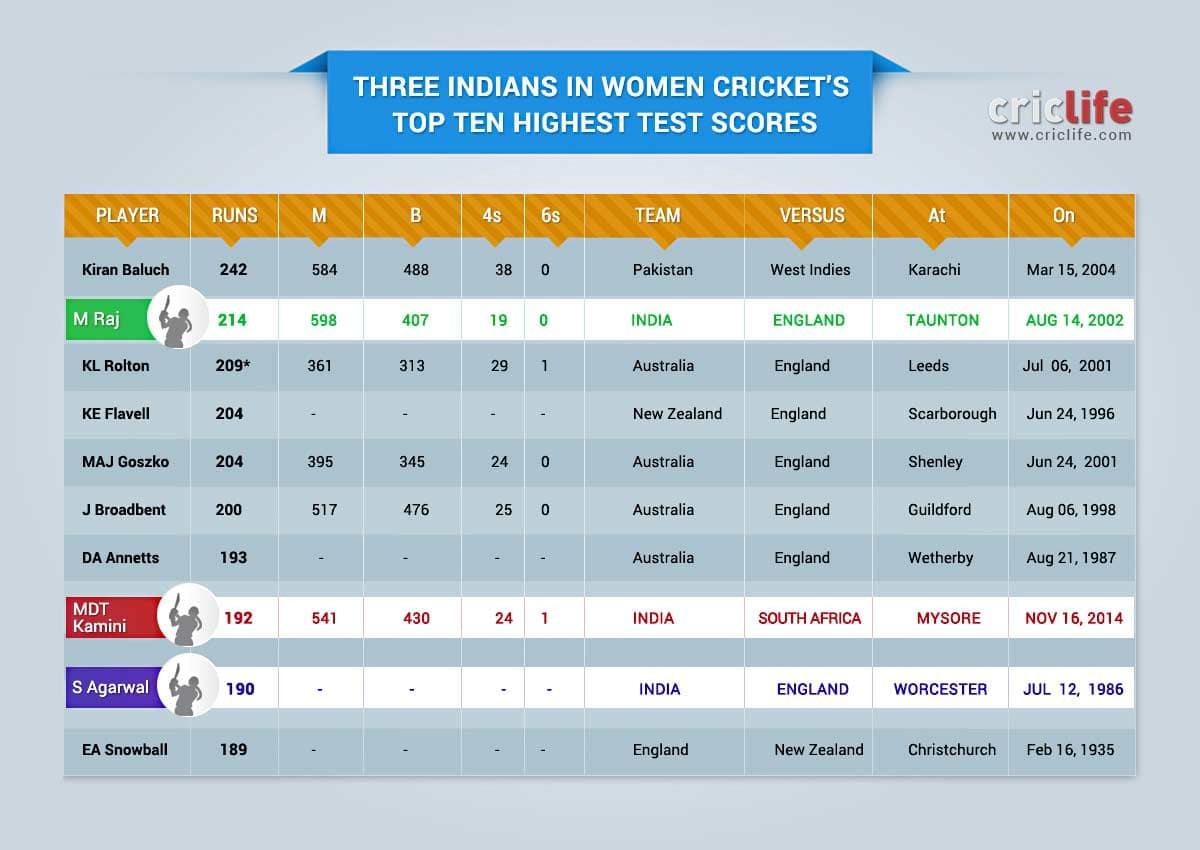Indicate a few pertinent items in this graphic. Kiran Baluch played for the national football team of Pakistan. The highest test score of KL Rolton is 209. MDT Kamini scored 6 sixes in the India-South Africa test match on Nov 16, 2014. On November 16, 2014, the India-Australia women's test match was held in Mysore. KE Flavell, a former professional rugby player, played for New Zealand. 